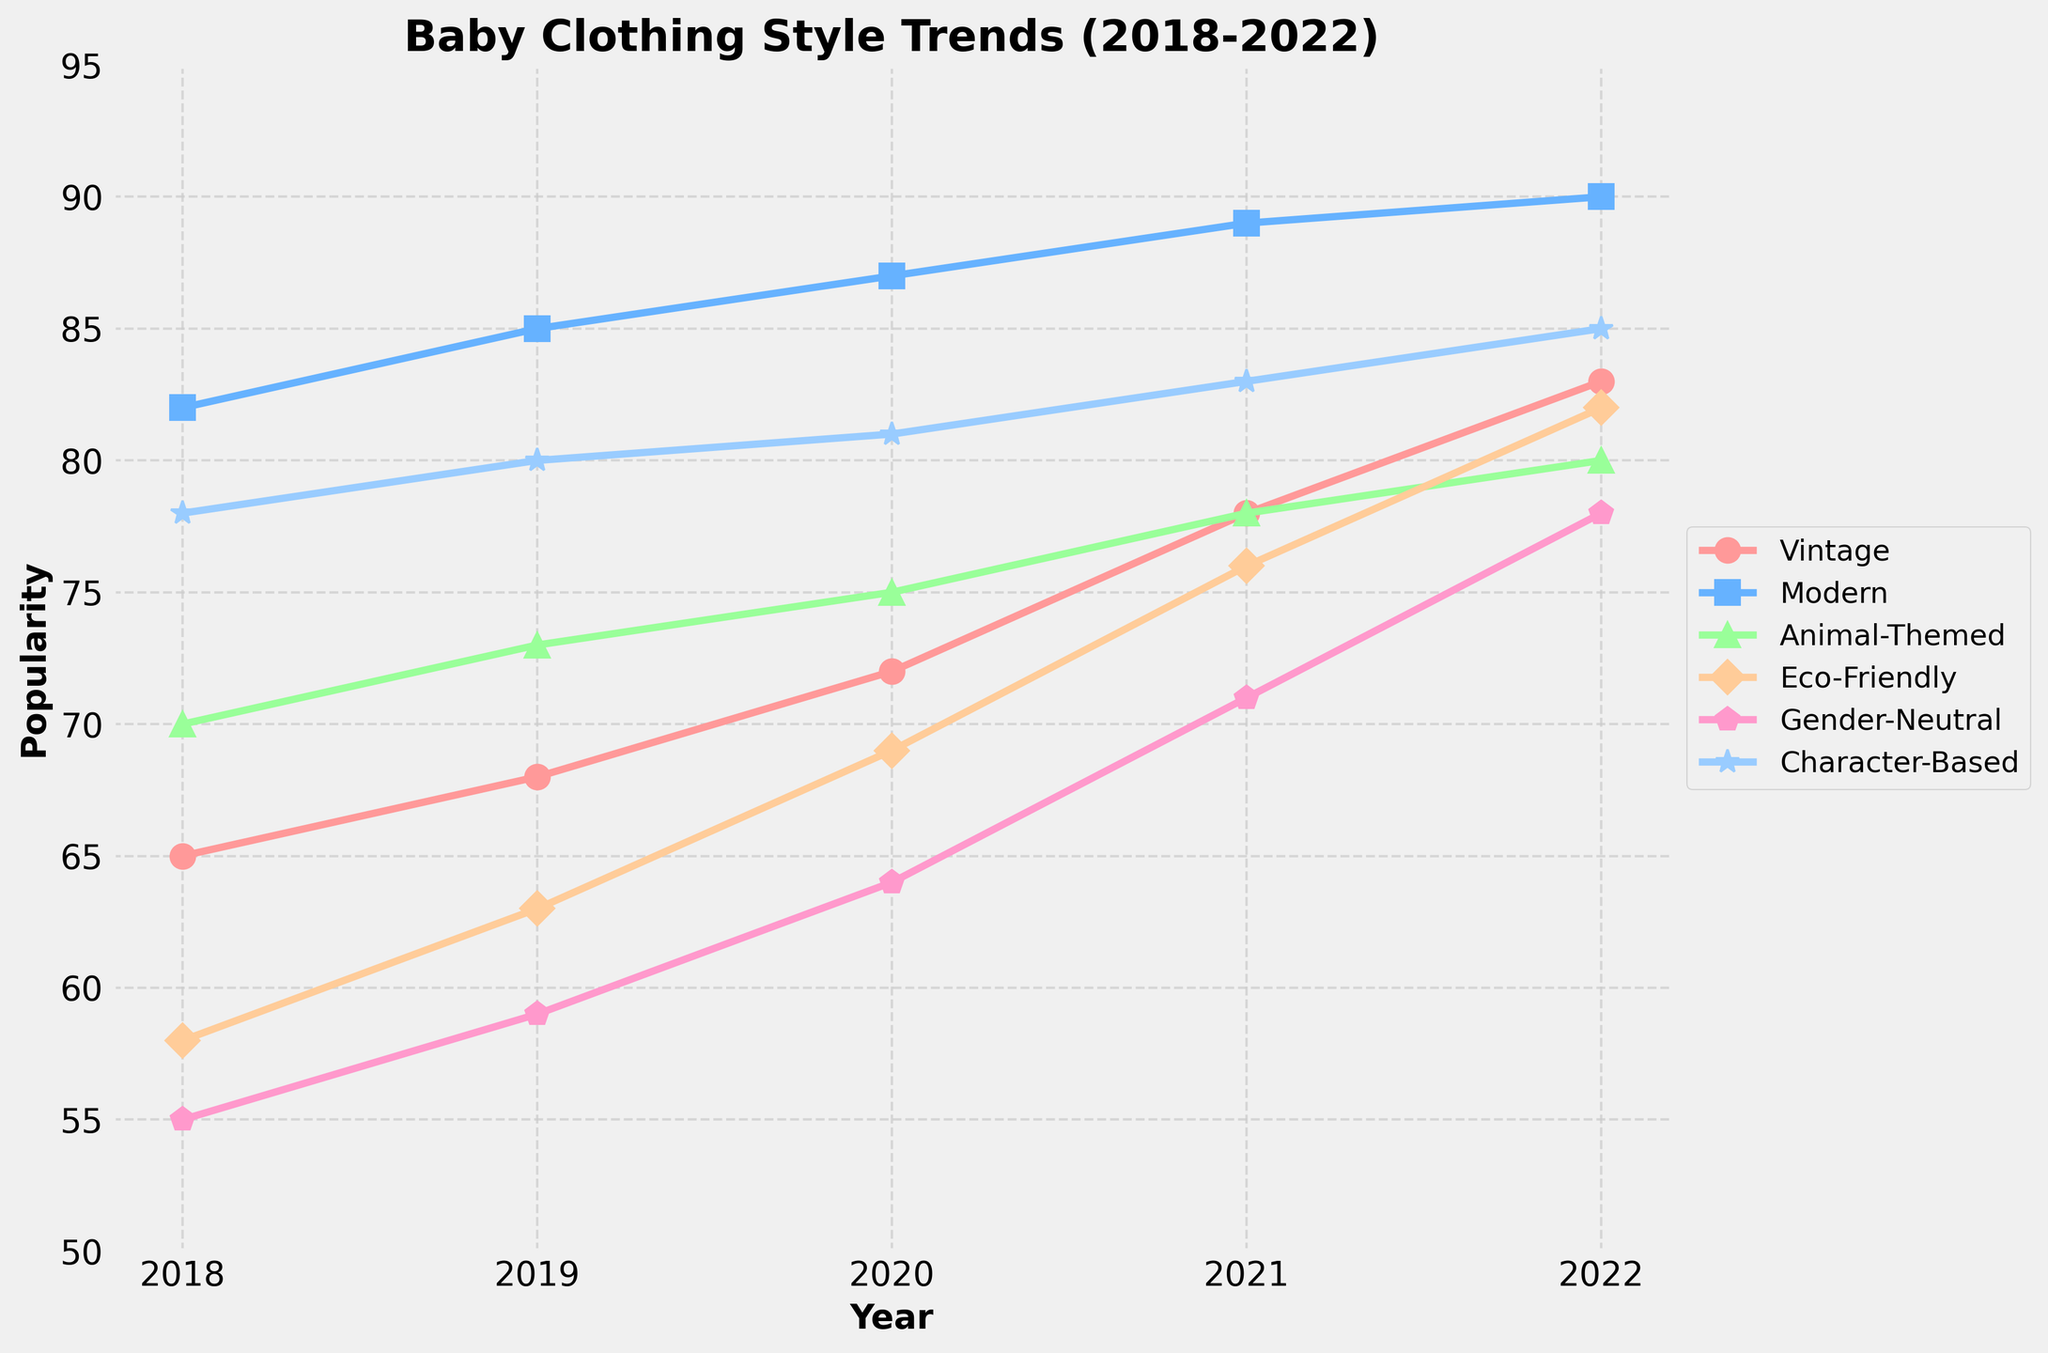What style experienced the highest increase in popularity from 2018 to 2022? To find the highest increase, we subtract the 2018 value from the 2022 value for each style: Vintage (83-65=18), Modern (90-82=8), Animal-Themed (80-70=10), Eco-Friendly (82-58=24), Gender-Neutral (78-55=23), Character-Based (85-78=7). Eco-Friendly has the highest increase of 24.
Answer: Eco-Friendly Which style had a higher popularity in 2020, Vintage or Animal-Themed? To determine this, we compare the 2020 values for both styles: Vintage (72) and Animal-Themed (75).
Answer: Animal-Themed What is the average popularity of Modern clothing style over the 5 years? We sum the values for Modern over the 5 years and divide by the number of years: (82+85+87+89+90)/5 = 433/5 = 86.6.
Answer: 86.6 Between which consecutive years did Gender-Neutral clothing experience the largest increase in popularity? We calculate the differences for Gender-Neutral between each consecutive year: 2018-2019 (59-55=4), 2019-2020 (64-59=5), 2020-2021 (71-64=7), 2021-2022 (78-71=7). The largest increase is from 2020 to 2021 or from 2021 to 2022 with an increase of 7.
Answer: 2021-2022 (or 2020-2021) What is the difference in popularity between the most popular and least popular style in 2021? We find the highest and lowest values in 2021: highest is Modern (89), lowest is Gender-Neutral (71). The difference is 89 - 71 = 18.
Answer: 18 Which style's popularity remained relatively stable from 2018 to 2022? We observe each style's trend: Modern (82 to 90), Animal-Themed (70 to 80), Eco-Friendly (58 to 82), Gender-Neutral (55 to 78), Character-Based (78 to 85), and Vintage (65 to 83). Modern shows the smallest increase (82 to 90).
Answer: Modern How much more popular was Character-Based clothing compared to Eco-Friendly in 2018? For 2018, subtract Eco-Friendly from Character-Based: 78-58=20.
Answer: 20 Does any style surpass the popularity score of 80 in 2019? We look at 2019 values: Modern (85), Vintage (68), Animal-Themed (73), Eco-Friendly (63), Gender-Neutral (59), Character-Based (80). Both Modern and Character-Based surpass 80.
Answer: Yes Which style had the second-highest popularity in 2022? For 2022, the values are Vintage (83), Modern (90), Animal-Themed (80), Eco-Friendly (82), Gender-Neutral (78), Character-Based (85). Character-Based is the second-highest after Modern.
Answer: Character-Based Identify the trend for Animal-Themed clothing from 2018 to 2022. We review the yearly values for Animal-Themed: 2018 (70), 2019 (73), 2020 (75), 2021 (78), 2022 (80). There is a consistent increase each year.
Answer: Increasing 